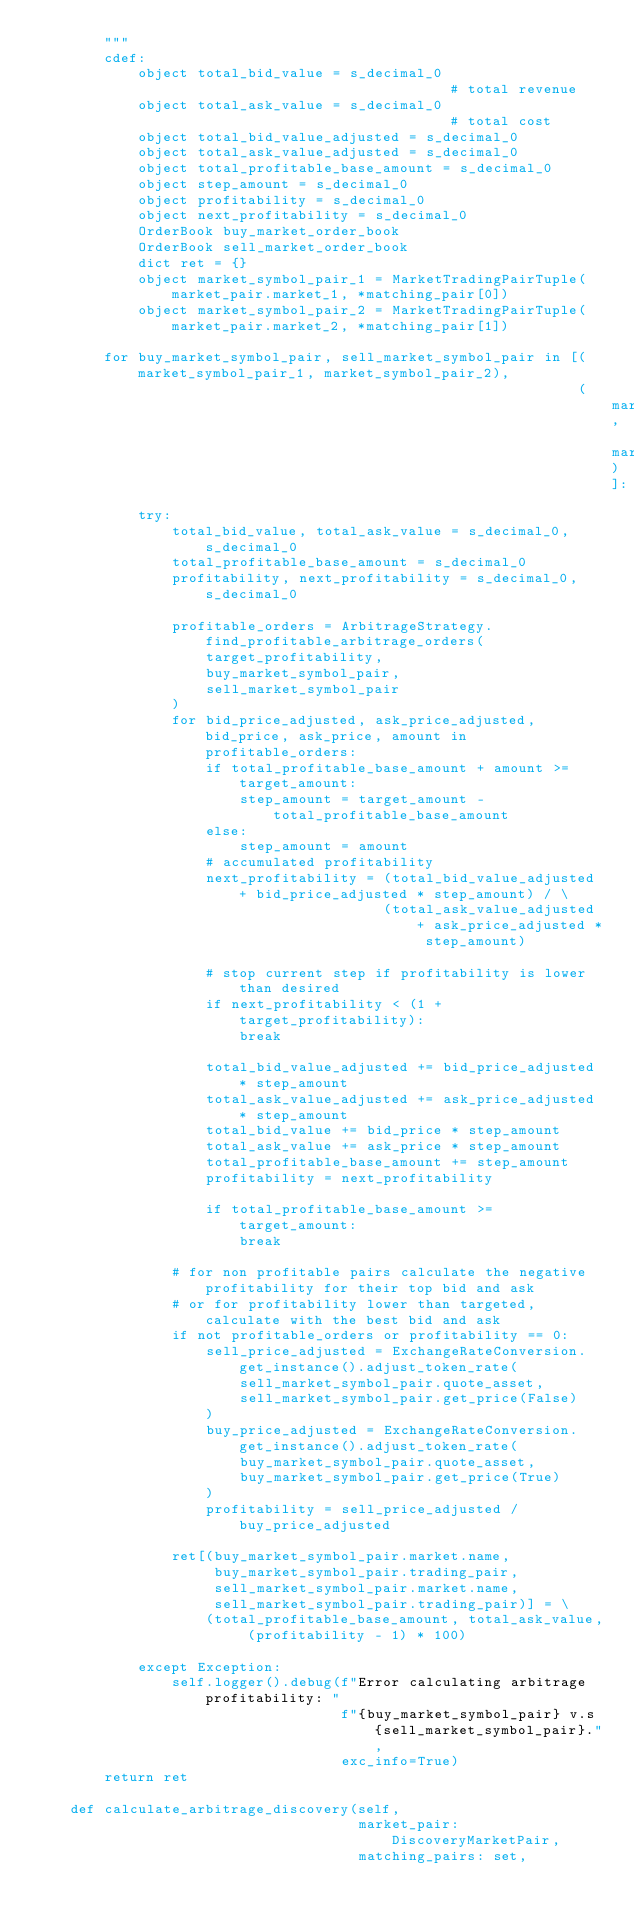<code> <loc_0><loc_0><loc_500><loc_500><_Cython_>        """
        cdef:
            object total_bid_value = s_decimal_0                                  # total revenue
            object total_ask_value = s_decimal_0                                  # total cost
            object total_bid_value_adjusted = s_decimal_0
            object total_ask_value_adjusted = s_decimal_0
            object total_profitable_base_amount = s_decimal_0
            object step_amount = s_decimal_0
            object profitability = s_decimal_0
            object next_profitability = s_decimal_0
            OrderBook buy_market_order_book
            OrderBook sell_market_order_book
            dict ret = {}
            object market_symbol_pair_1 = MarketTradingPairTuple(market_pair.market_1, *matching_pair[0])
            object market_symbol_pair_2 = MarketTradingPairTuple(market_pair.market_2, *matching_pair[1])

        for buy_market_symbol_pair, sell_market_symbol_pair in [(market_symbol_pair_1, market_symbol_pair_2),
                                                                (market_symbol_pair_2, market_symbol_pair_1)]:
            try:
                total_bid_value, total_ask_value = s_decimal_0, s_decimal_0
                total_profitable_base_amount = s_decimal_0
                profitability, next_profitability = s_decimal_0, s_decimal_0

                profitable_orders = ArbitrageStrategy.find_profitable_arbitrage_orders(
                    target_profitability,
                    buy_market_symbol_pair,
                    sell_market_symbol_pair
                )
                for bid_price_adjusted, ask_price_adjusted, bid_price, ask_price, amount in profitable_orders:
                    if total_profitable_base_amount + amount >= target_amount:
                        step_amount = target_amount - total_profitable_base_amount
                    else:
                        step_amount = amount
                    # accumulated profitability
                    next_profitability = (total_bid_value_adjusted + bid_price_adjusted * step_amount) / \
                                         (total_ask_value_adjusted + ask_price_adjusted * step_amount)

                    # stop current step if profitability is lower than desired
                    if next_profitability < (1 + target_profitability):
                        break

                    total_bid_value_adjusted += bid_price_adjusted * step_amount
                    total_ask_value_adjusted += ask_price_adjusted * step_amount
                    total_bid_value += bid_price * step_amount
                    total_ask_value += ask_price * step_amount
                    total_profitable_base_amount += step_amount
                    profitability = next_profitability

                    if total_profitable_base_amount >= target_amount:
                        break

                # for non profitable pairs calculate the negative profitability for their top bid and ask
                # or for profitability lower than targeted, calculate with the best bid and ask
                if not profitable_orders or profitability == 0:
                    sell_price_adjusted = ExchangeRateConversion.get_instance().adjust_token_rate(
                        sell_market_symbol_pair.quote_asset,
                        sell_market_symbol_pair.get_price(False)
                    )
                    buy_price_adjusted = ExchangeRateConversion.get_instance().adjust_token_rate(
                        buy_market_symbol_pair.quote_asset,
                        buy_market_symbol_pair.get_price(True)
                    )
                    profitability = sell_price_adjusted / buy_price_adjusted

                ret[(buy_market_symbol_pair.market.name,
                     buy_market_symbol_pair.trading_pair,
                     sell_market_symbol_pair.market.name,
                     sell_market_symbol_pair.trading_pair)] = \
                    (total_profitable_base_amount, total_ask_value, (profitability - 1) * 100)

            except Exception:
                self.logger().debug(f"Error calculating arbitrage profitability: "
                                    f"{buy_market_symbol_pair} v.s {sell_market_symbol_pair}.",
                                    exc_info=True)
        return ret

    def calculate_arbitrage_discovery(self,
                                      market_pair: DiscoveryMarketPair,
                                      matching_pairs: set,</code> 